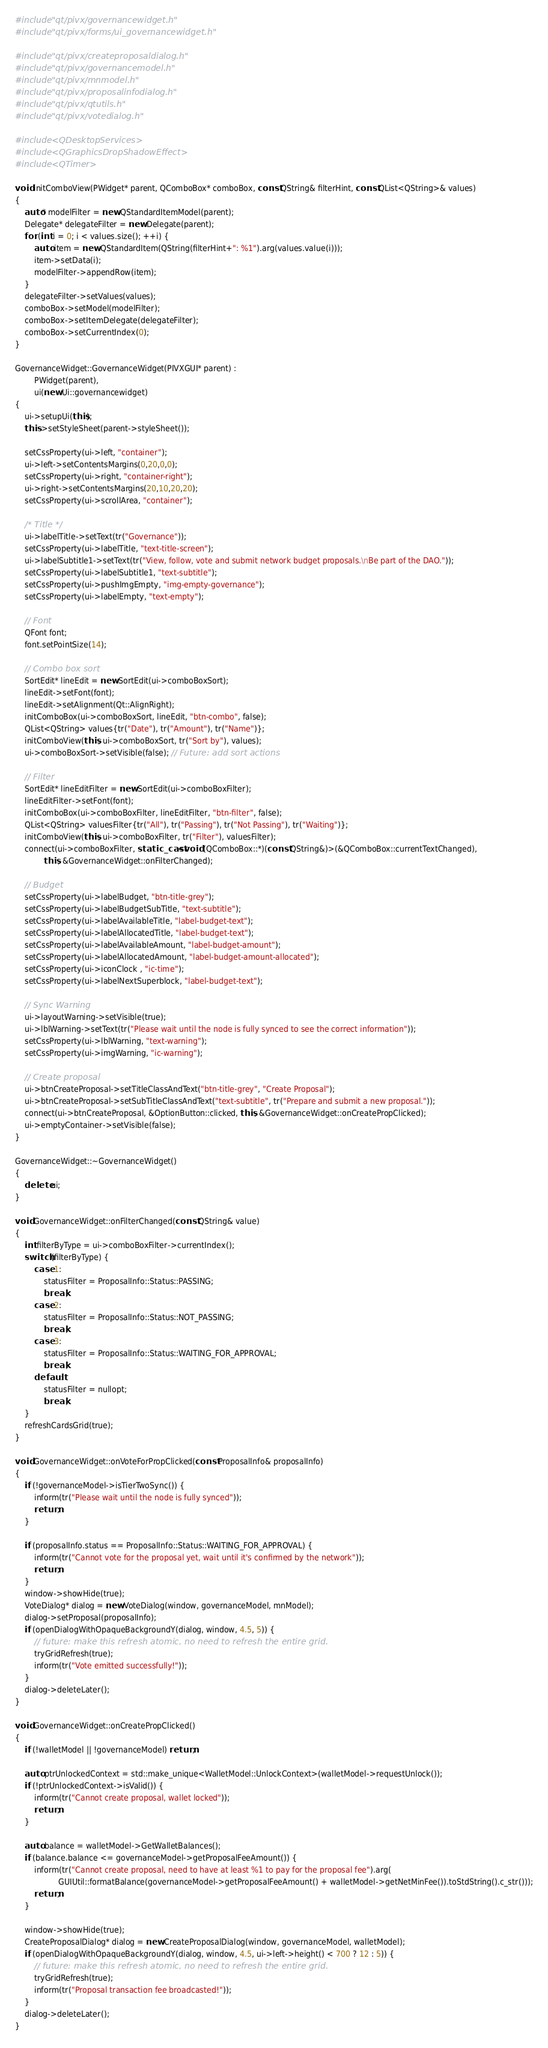Convert code to text. <code><loc_0><loc_0><loc_500><loc_500><_C++_>#include "qt/pivx/governancewidget.h"
#include "qt/pivx/forms/ui_governancewidget.h"

#include "qt/pivx/createproposaldialog.h"
#include "qt/pivx/governancemodel.h"
#include "qt/pivx/mnmodel.h"
#include "qt/pivx/proposalinfodialog.h"
#include "qt/pivx/qtutils.h"
#include "qt/pivx/votedialog.h"

#include <QDesktopServices>
#include <QGraphicsDropShadowEffect>
#include <QTimer>

void initComboView(PWidget* parent, QComboBox* comboBox, const QString& filterHint, const QList<QString>& values)
{
    auto* modelFilter = new QStandardItemModel(parent);
    Delegate* delegateFilter = new Delegate(parent);
    for (int i = 0; i < values.size(); ++i) {
        auto item = new QStandardItem(QString(filterHint+": %1").arg(values.value(i)));
        item->setData(i);
        modelFilter->appendRow(item);
    }
    delegateFilter->setValues(values);
    comboBox->setModel(modelFilter);
    comboBox->setItemDelegate(delegateFilter);
    comboBox->setCurrentIndex(0);
}

GovernanceWidget::GovernanceWidget(PIVXGUI* parent) :
        PWidget(parent),
        ui(new Ui::governancewidget)
{
    ui->setupUi(this);
    this->setStyleSheet(parent->styleSheet());

    setCssProperty(ui->left, "container");
    ui->left->setContentsMargins(0,20,0,0);
    setCssProperty(ui->right, "container-right");
    ui->right->setContentsMargins(20,10,20,20);
    setCssProperty(ui->scrollArea, "container");

    /* Title */
    ui->labelTitle->setText(tr("Governance"));
    setCssProperty(ui->labelTitle, "text-title-screen");
    ui->labelSubtitle1->setText(tr("View, follow, vote and submit network budget proposals.\nBe part of the DAO."));
    setCssProperty(ui->labelSubtitle1, "text-subtitle");
    setCssProperty(ui->pushImgEmpty, "img-empty-governance");
    setCssProperty(ui->labelEmpty, "text-empty");

    // Font
    QFont font;
    font.setPointSize(14);

    // Combo box sort
    SortEdit* lineEdit = new SortEdit(ui->comboBoxSort);
    lineEdit->setFont(font);
    lineEdit->setAlignment(Qt::AlignRight);
    initComboBox(ui->comboBoxSort, lineEdit, "btn-combo", false);
    QList<QString> values{tr("Date"), tr("Amount"), tr("Name")};
    initComboView(this, ui->comboBoxSort, tr("Sort by"), values);
    ui->comboBoxSort->setVisible(false); // Future: add sort actions

    // Filter
    SortEdit* lineEditFilter = new SortEdit(ui->comboBoxFilter);
    lineEditFilter->setFont(font);
    initComboBox(ui->comboBoxFilter, lineEditFilter, "btn-filter", false);
    QList<QString> valuesFilter{tr("All"), tr("Passing"), tr("Not Passing"), tr("Waiting")};
    initComboView(this, ui->comboBoxFilter, tr("Filter"), valuesFilter);
    connect(ui->comboBoxFilter, static_cast<void (QComboBox::*)(const QString&)>(&QComboBox::currentTextChanged),
            this, &GovernanceWidget::onFilterChanged);

    // Budget
    setCssProperty(ui->labelBudget, "btn-title-grey");
    setCssProperty(ui->labelBudgetSubTitle, "text-subtitle");
    setCssProperty(ui->labelAvailableTitle, "label-budget-text");
    setCssProperty(ui->labelAllocatedTitle, "label-budget-text");
    setCssProperty(ui->labelAvailableAmount, "label-budget-amount");
    setCssProperty(ui->labelAllocatedAmount, "label-budget-amount-allocated");
    setCssProperty(ui->iconClock , "ic-time");
    setCssProperty(ui->labelNextSuperblock, "label-budget-text");

    // Sync Warning
    ui->layoutWarning->setVisible(true);
    ui->lblWarning->setText(tr("Please wait until the node is fully synced to see the correct information"));
    setCssProperty(ui->lblWarning, "text-warning");
    setCssProperty(ui->imgWarning, "ic-warning");

    // Create proposal
    ui->btnCreateProposal->setTitleClassAndText("btn-title-grey", "Create Proposal");
    ui->btnCreateProposal->setSubTitleClassAndText("text-subtitle", tr("Prepare and submit a new proposal."));
    connect(ui->btnCreateProposal, &OptionButton::clicked, this, &GovernanceWidget::onCreatePropClicked);
    ui->emptyContainer->setVisible(false);
}

GovernanceWidget::~GovernanceWidget()
{
    delete ui;
}

void GovernanceWidget::onFilterChanged(const QString& value)
{
    int filterByType = ui->comboBoxFilter->currentIndex();
    switch (filterByType) {
        case 1:
            statusFilter = ProposalInfo::Status::PASSING;
            break;
        case 2:
            statusFilter = ProposalInfo::Status::NOT_PASSING;
            break;
        case 3:
            statusFilter = ProposalInfo::Status::WAITING_FOR_APPROVAL;
            break;
        default:
            statusFilter = nullopt;
            break;
    }
    refreshCardsGrid(true);
}

void GovernanceWidget::onVoteForPropClicked(const ProposalInfo& proposalInfo)
{
    if (!governanceModel->isTierTwoSync()) {
        inform(tr("Please wait until the node is fully synced"));
        return;
    }

    if (proposalInfo.status == ProposalInfo::Status::WAITING_FOR_APPROVAL) {
        inform(tr("Cannot vote for the proposal yet, wait until it's confirmed by the network"));
        return;
    }
    window->showHide(true);
    VoteDialog* dialog = new VoteDialog(window, governanceModel, mnModel);
    dialog->setProposal(proposalInfo);
    if (openDialogWithOpaqueBackgroundY(dialog, window, 4.5, 5)) {
        // future: make this refresh atomic, no need to refresh the entire grid.
        tryGridRefresh(true);
        inform(tr("Vote emitted successfully!"));
    }
    dialog->deleteLater();
}

void GovernanceWidget::onCreatePropClicked()
{
    if (!walletModel || !governanceModel) return;

    auto ptrUnlockedContext = std::make_unique<WalletModel::UnlockContext>(walletModel->requestUnlock());
    if (!ptrUnlockedContext->isValid()) {
        inform(tr("Cannot create proposal, wallet locked"));
        return;
    }

    auto balance = walletModel->GetWalletBalances();
    if (balance.balance <= governanceModel->getProposalFeeAmount()) {
        inform(tr("Cannot create proposal, need to have at least %1 to pay for the proposal fee").arg(
                  GUIUtil::formatBalance(governanceModel->getProposalFeeAmount() + walletModel->getNetMinFee()).toStdString().c_str()));
        return;
    }

    window->showHide(true);
    CreateProposalDialog* dialog = new CreateProposalDialog(window, governanceModel, walletModel);
    if (openDialogWithOpaqueBackgroundY(dialog, window, 4.5, ui->left->height() < 700 ? 12 : 5)) {
        // future: make this refresh atomic, no need to refresh the entire grid.
        tryGridRefresh(true);
        inform(tr("Proposal transaction fee broadcasted!"));
    }
    dialog->deleteLater();
}
</code> 